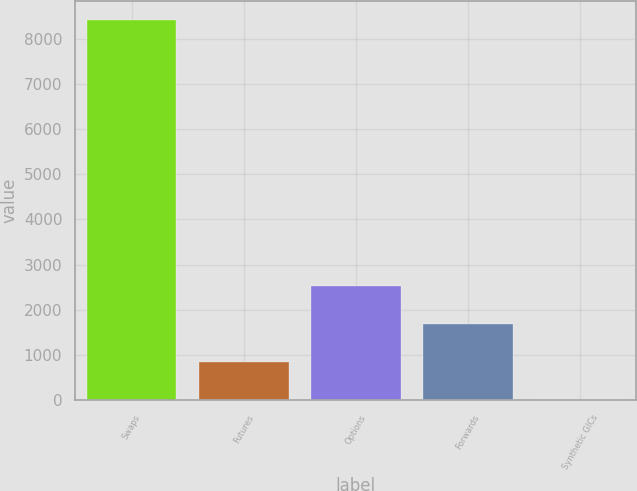Convert chart to OTSL. <chart><loc_0><loc_0><loc_500><loc_500><bar_chart><fcel>Swaps<fcel>Futures<fcel>Options<fcel>Forwards<fcel>Synthetic GICs<nl><fcel>8423<fcel>848.6<fcel>2531.8<fcel>1690.2<fcel>7<nl></chart> 